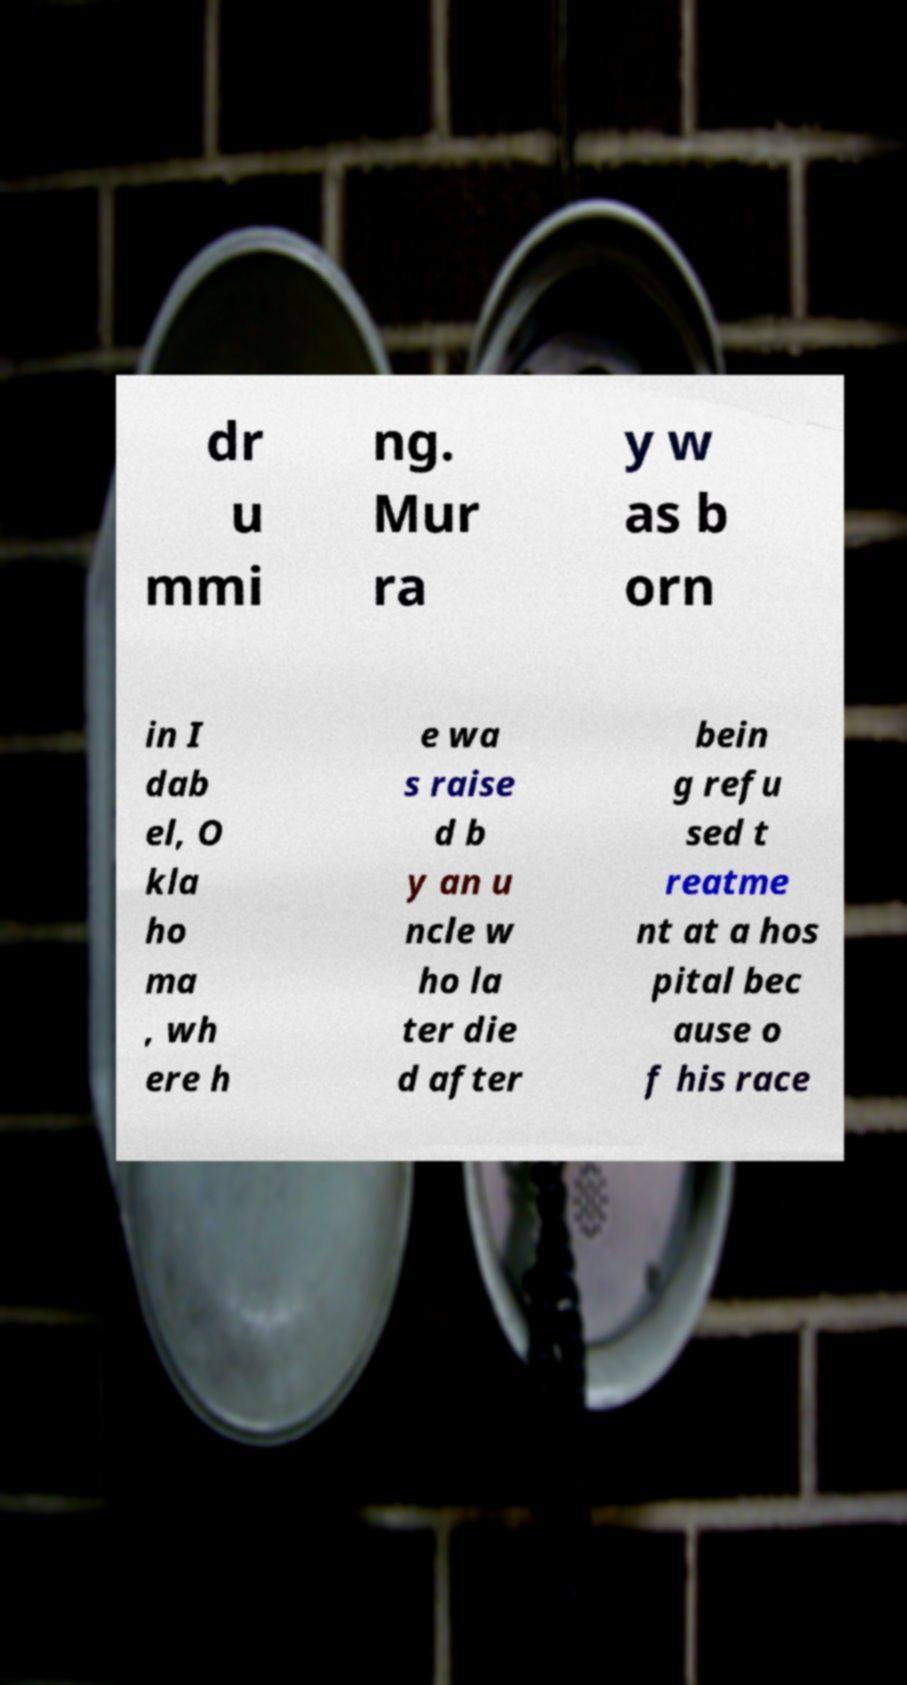There's text embedded in this image that I need extracted. Can you transcribe it verbatim? dr u mmi ng. Mur ra y w as b orn in I dab el, O kla ho ma , wh ere h e wa s raise d b y an u ncle w ho la ter die d after bein g refu sed t reatme nt at a hos pital bec ause o f his race 